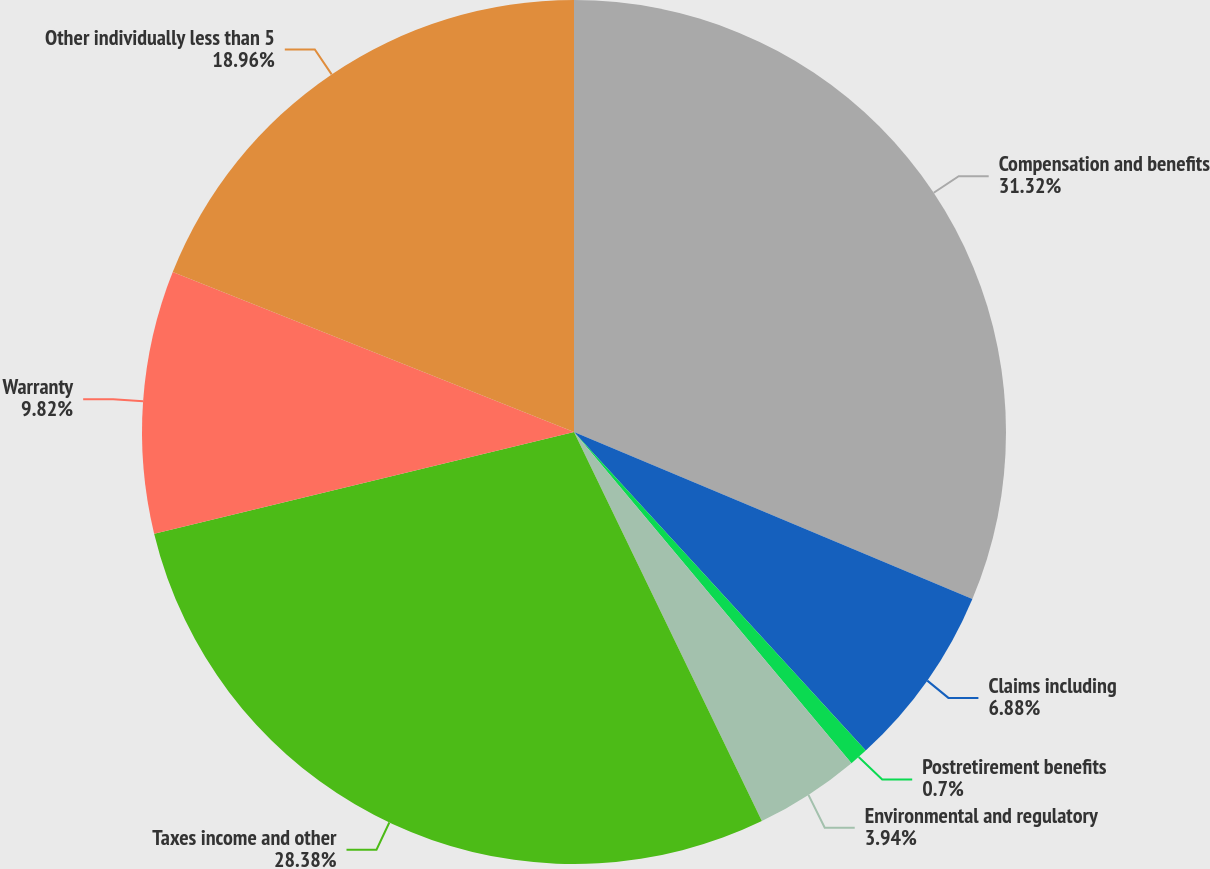Convert chart to OTSL. <chart><loc_0><loc_0><loc_500><loc_500><pie_chart><fcel>Compensation and benefits<fcel>Claims including<fcel>Postretirement benefits<fcel>Environmental and regulatory<fcel>Taxes income and other<fcel>Warranty<fcel>Other individually less than 5<nl><fcel>31.32%<fcel>6.88%<fcel>0.7%<fcel>3.94%<fcel>28.38%<fcel>9.82%<fcel>18.96%<nl></chart> 